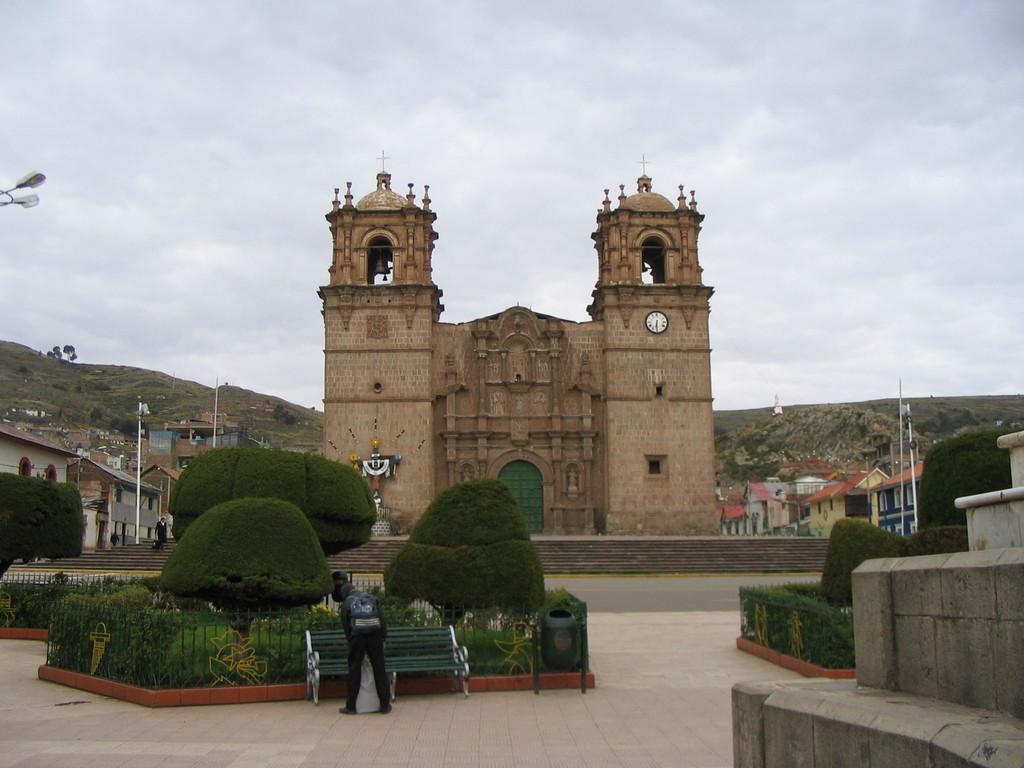In one or two sentences, can you explain what this image depicts? In this image we can see a fort. There are many buildings at the either sides of the image. There are many trees and plants in the image. There is a bench in the image. A person is standing near the bench. There is a person at the left side of the image. There is the cloudy sky in the image. There are few street lights in the image. There are staircases in the image. 